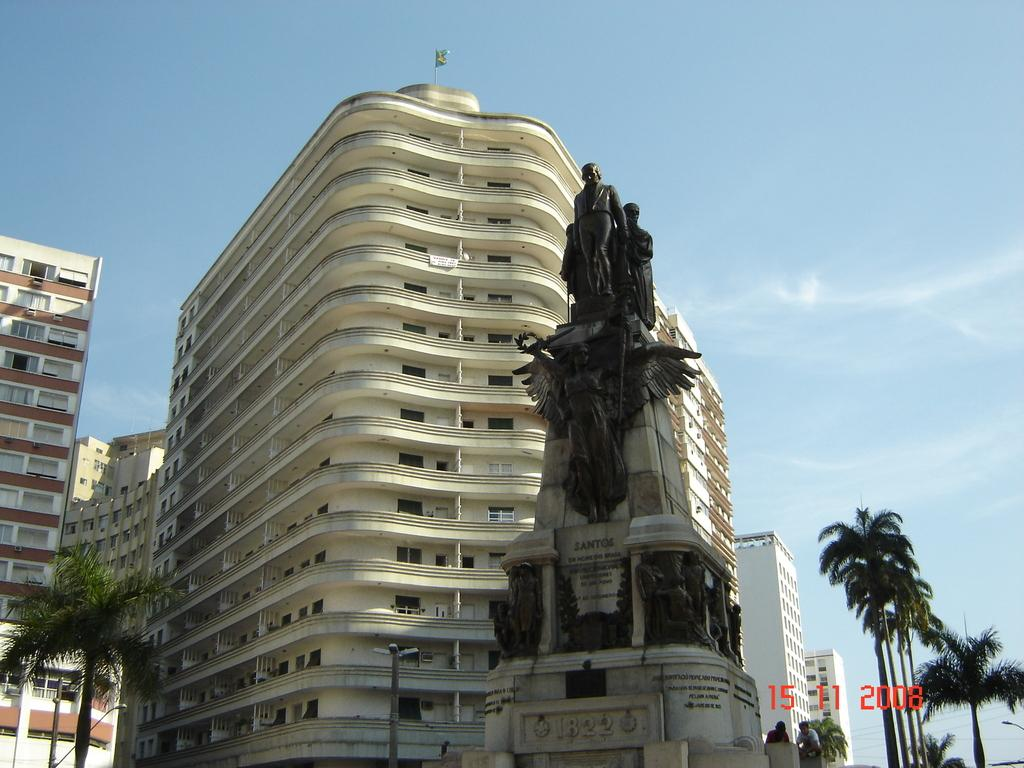<image>
Provide a brief description of the given image. Statue with the year 1822 near the bottome next to a building. 